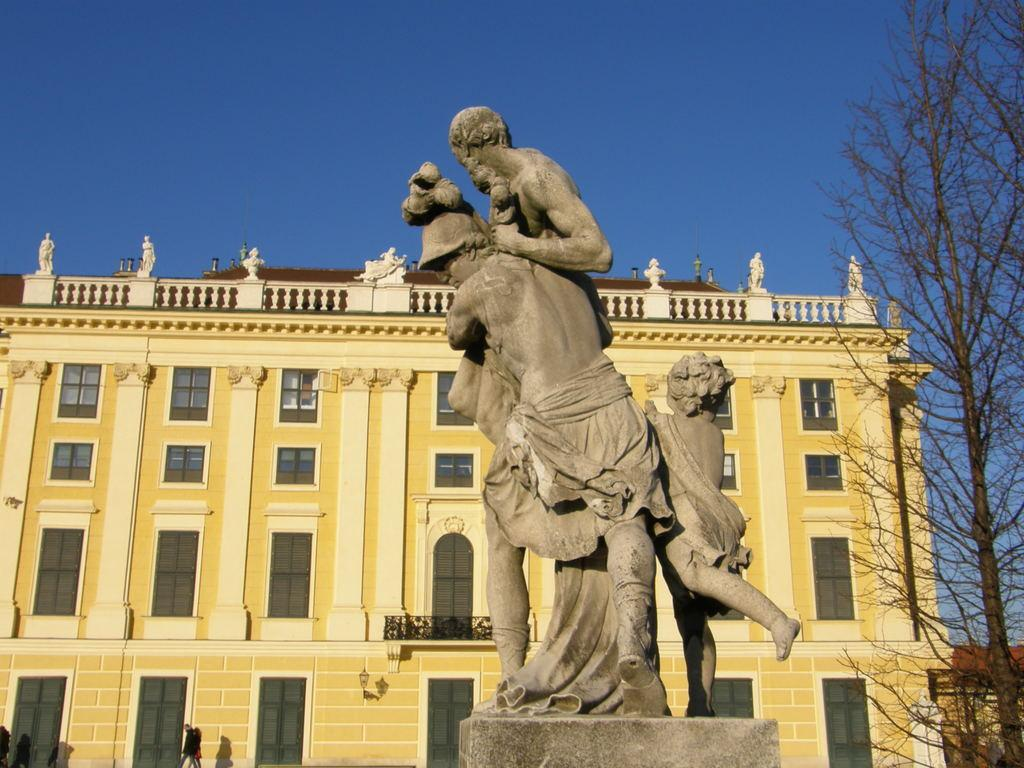What type of structure is visible in the image? There is a building in the image. What feature can be seen on the building? The building has windows. What type of vegetation is present in the image? There are dry trees in the image. What are the people in the image doing? There are people walking in the image. What is located in front of the building? There is a statue in front of the building. What is the color of the sky in the image? The sky is blue in color. How many bananas are hanging from the trees in the image? There are no bananas present in the image; the trees are dry. What time of day is it in the image, given that it is morning? The time of day is not mentioned in the image, and there is no indication that it is morning. 